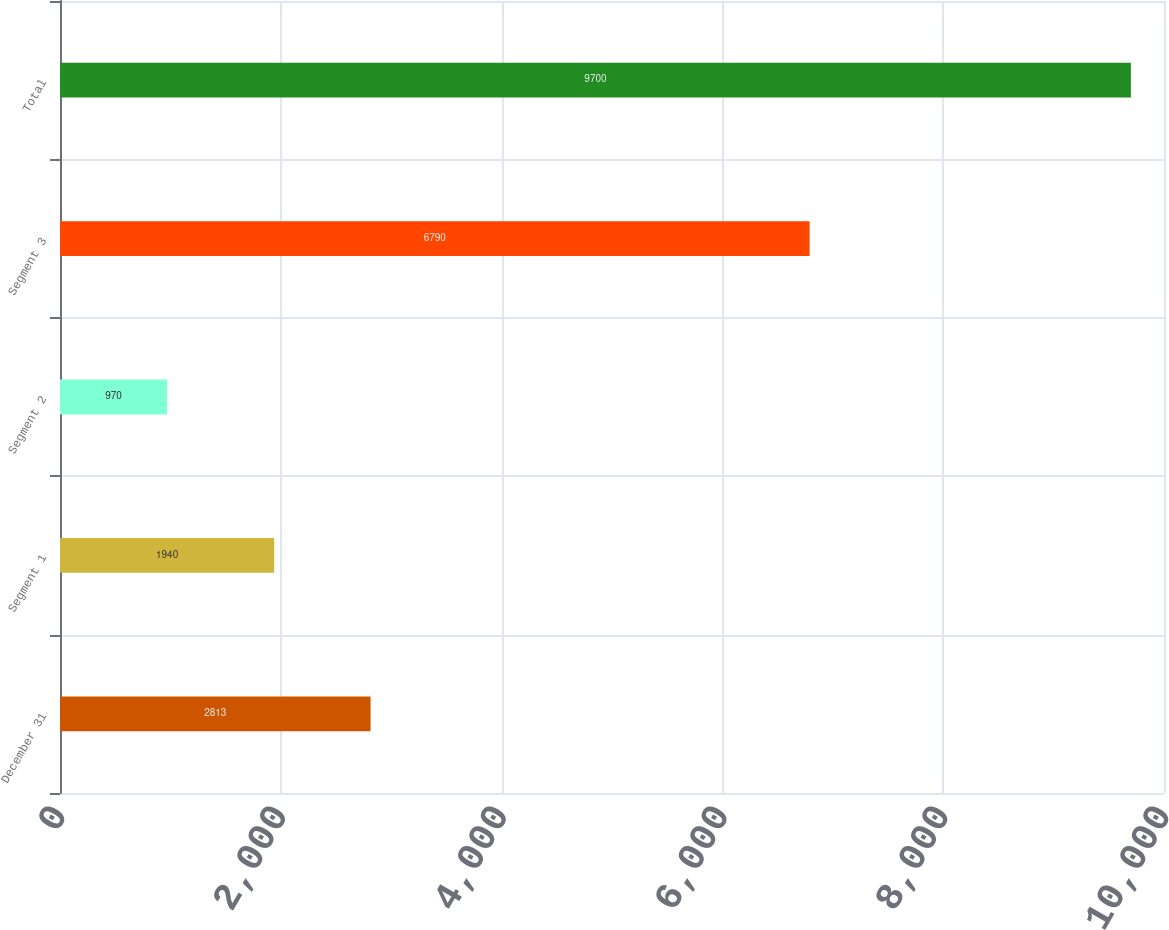Convert chart to OTSL. <chart><loc_0><loc_0><loc_500><loc_500><bar_chart><fcel>December 31<fcel>Segment 1<fcel>Segment 2<fcel>Segment 3<fcel>Total<nl><fcel>2813<fcel>1940<fcel>970<fcel>6790<fcel>9700<nl></chart> 